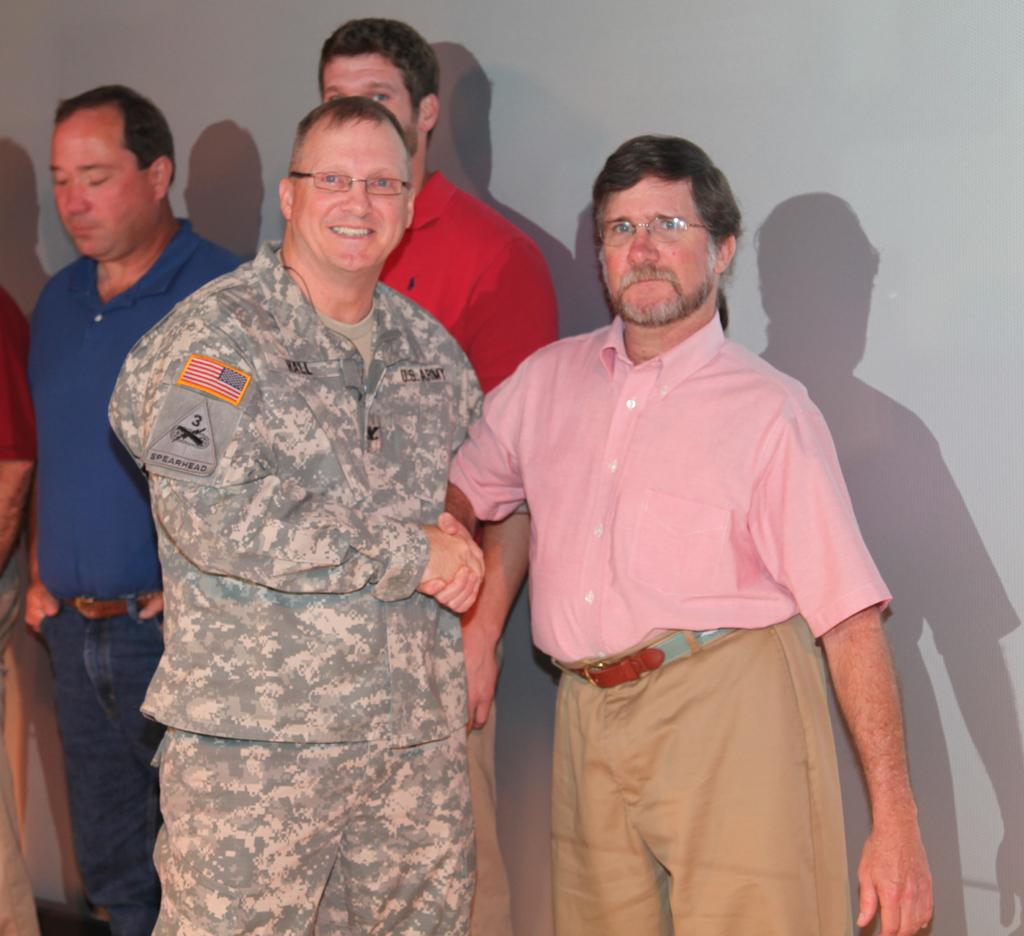What is the color of the wall in the image? The wall in the image is white. What can be seen in front of the wall in the image? There are people standing in the image. What type of collar is being worn by the person in the image? There is no collar visible in the image, as the people are not wearing any clothing that would have a collar. 